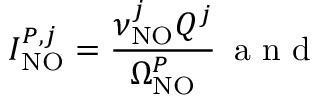<formula> <loc_0><loc_0><loc_500><loc_500>I _ { N O } ^ { P , j } = \frac { \nu _ { N O } ^ { j } Q ^ { j } } { \Omega _ { N O } ^ { P } } \, a n d</formula> 